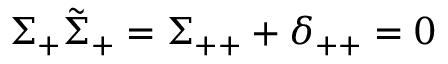Convert formula to latex. <formula><loc_0><loc_0><loc_500><loc_500>\Sigma _ { + } \tilde { \Sigma } _ { + } = \Sigma _ { + + } + \delta _ { + + } = 0</formula> 